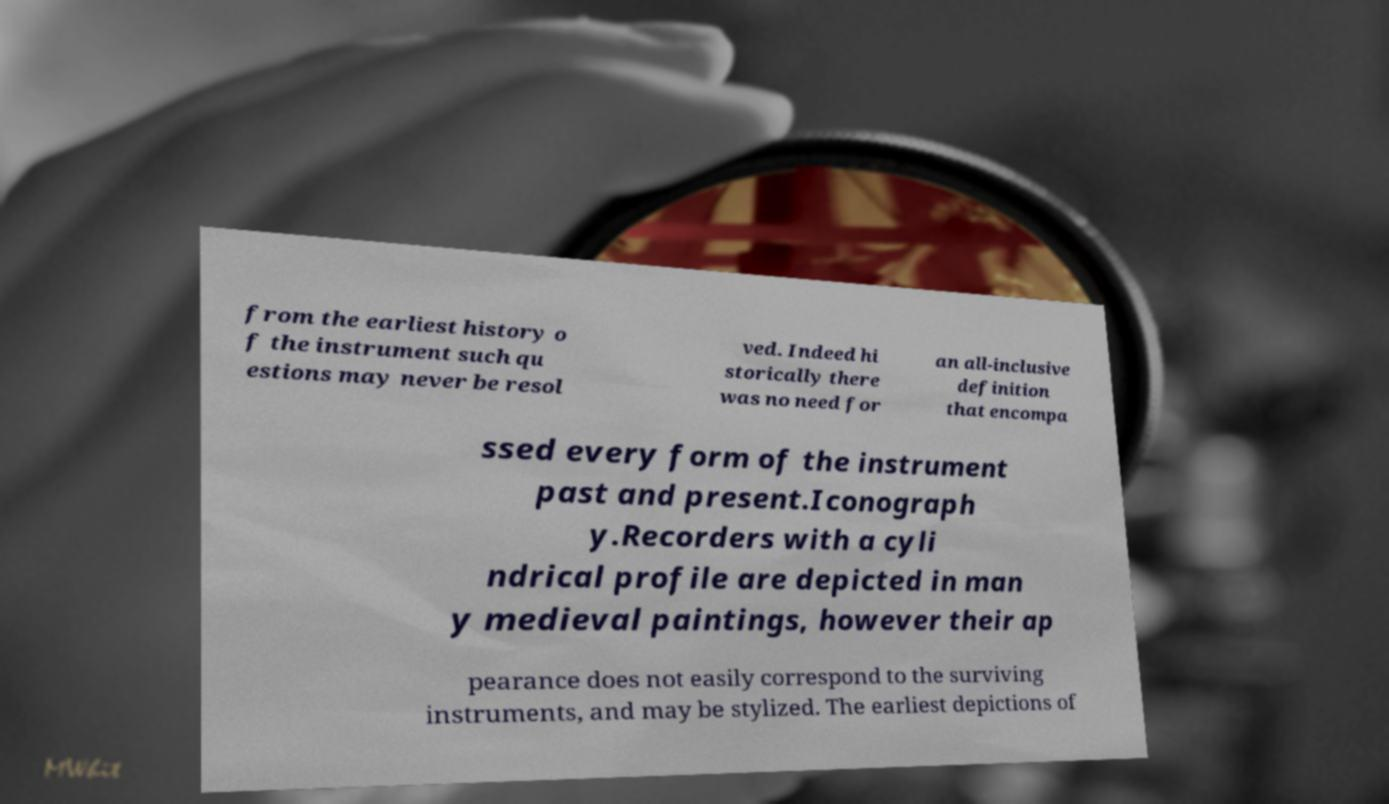Please read and relay the text visible in this image. What does it say? from the earliest history o f the instrument such qu estions may never be resol ved. Indeed hi storically there was no need for an all-inclusive definition that encompa ssed every form of the instrument past and present.Iconograph y.Recorders with a cyli ndrical profile are depicted in man y medieval paintings, however their ap pearance does not easily correspond to the surviving instruments, and may be stylized. The earliest depictions of 